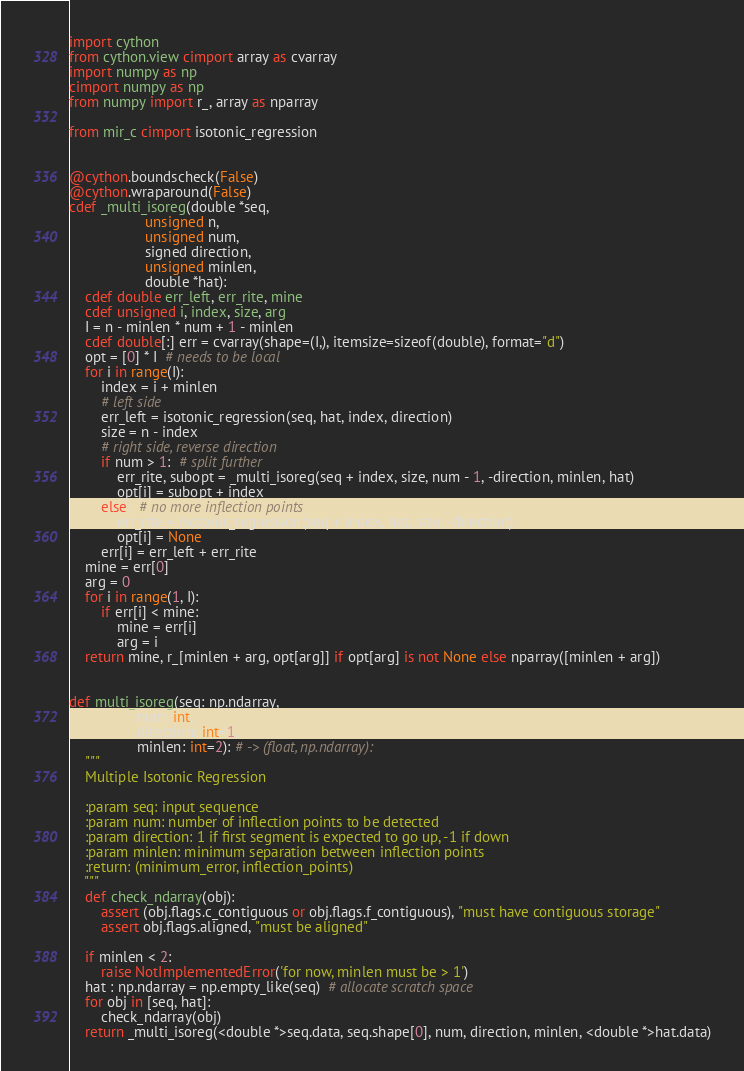Convert code to text. <code><loc_0><loc_0><loc_500><loc_500><_Cython_>import cython
from cython.view cimport array as cvarray
import numpy as np
cimport numpy as np
from numpy import r_, array as nparray

from mir_c cimport isotonic_regression


@cython.boundscheck(False)
@cython.wraparound(False)
cdef _multi_isoreg(double *seq,
                   unsigned n,
                   unsigned num,
                   signed direction,
                   unsigned minlen,
                   double *hat):
    cdef double err_left, err_rite, mine
    cdef unsigned i, index, size, arg
    I = n - minlen * num + 1 - minlen
    cdef double[:] err = cvarray(shape=(I,), itemsize=sizeof(double), format="d")
    opt = [0] * I  # needs to be local
    for i in range(I):
        index = i + minlen
        # left side
        err_left = isotonic_regression(seq, hat, index, direction)
        size = n - index
        # right side, reverse direction
        if num > 1:  # split further
            err_rite, subopt = _multi_isoreg(seq + index, size, num - 1, -direction, minlen, hat)
            opt[i] = subopt + index
        else:  # no more inflection points
            err_rite = isotonic_regression(seq + index, hat, size, -direction)
            opt[i] = None
        err[i] = err_left + err_rite
    mine = err[0]
    arg = 0
    for i in range(1, I):
        if err[i] < mine:
            mine = err[i]
            arg = i
    return mine, r_[minlen + arg, opt[arg]] if opt[arg] is not None else nparray([minlen + arg])


def multi_isoreg(seq: np.ndarray,
                 num: int,
                 direction: int=1,
                 minlen: int=2): # -> (float, np.ndarray):
    """
    Multiple Isotonic Regression

    :param seq: input sequence
    :param num: number of inflection points to be detected
    :param direction: 1 if first segment is expected to go up, -1 if down
    :param minlen: minimum separation between inflection points
    :return: (minimum_error, inflection_points)
    """
    def check_ndarray(obj):
        assert (obj.flags.c_contiguous or obj.flags.f_contiguous), "must have contiguous storage"
        assert obj.flags.aligned, "must be aligned"

    if minlen < 2:
        raise NotImplementedError('for now, minlen must be > 1')
    hat : np.ndarray = np.empty_like(seq)  # allocate scratch space
    for obj in [seq, hat]:
        check_ndarray(obj)
    return _multi_isoreg(<double *>seq.data, seq.shape[0], num, direction, minlen, <double *>hat.data)


</code> 